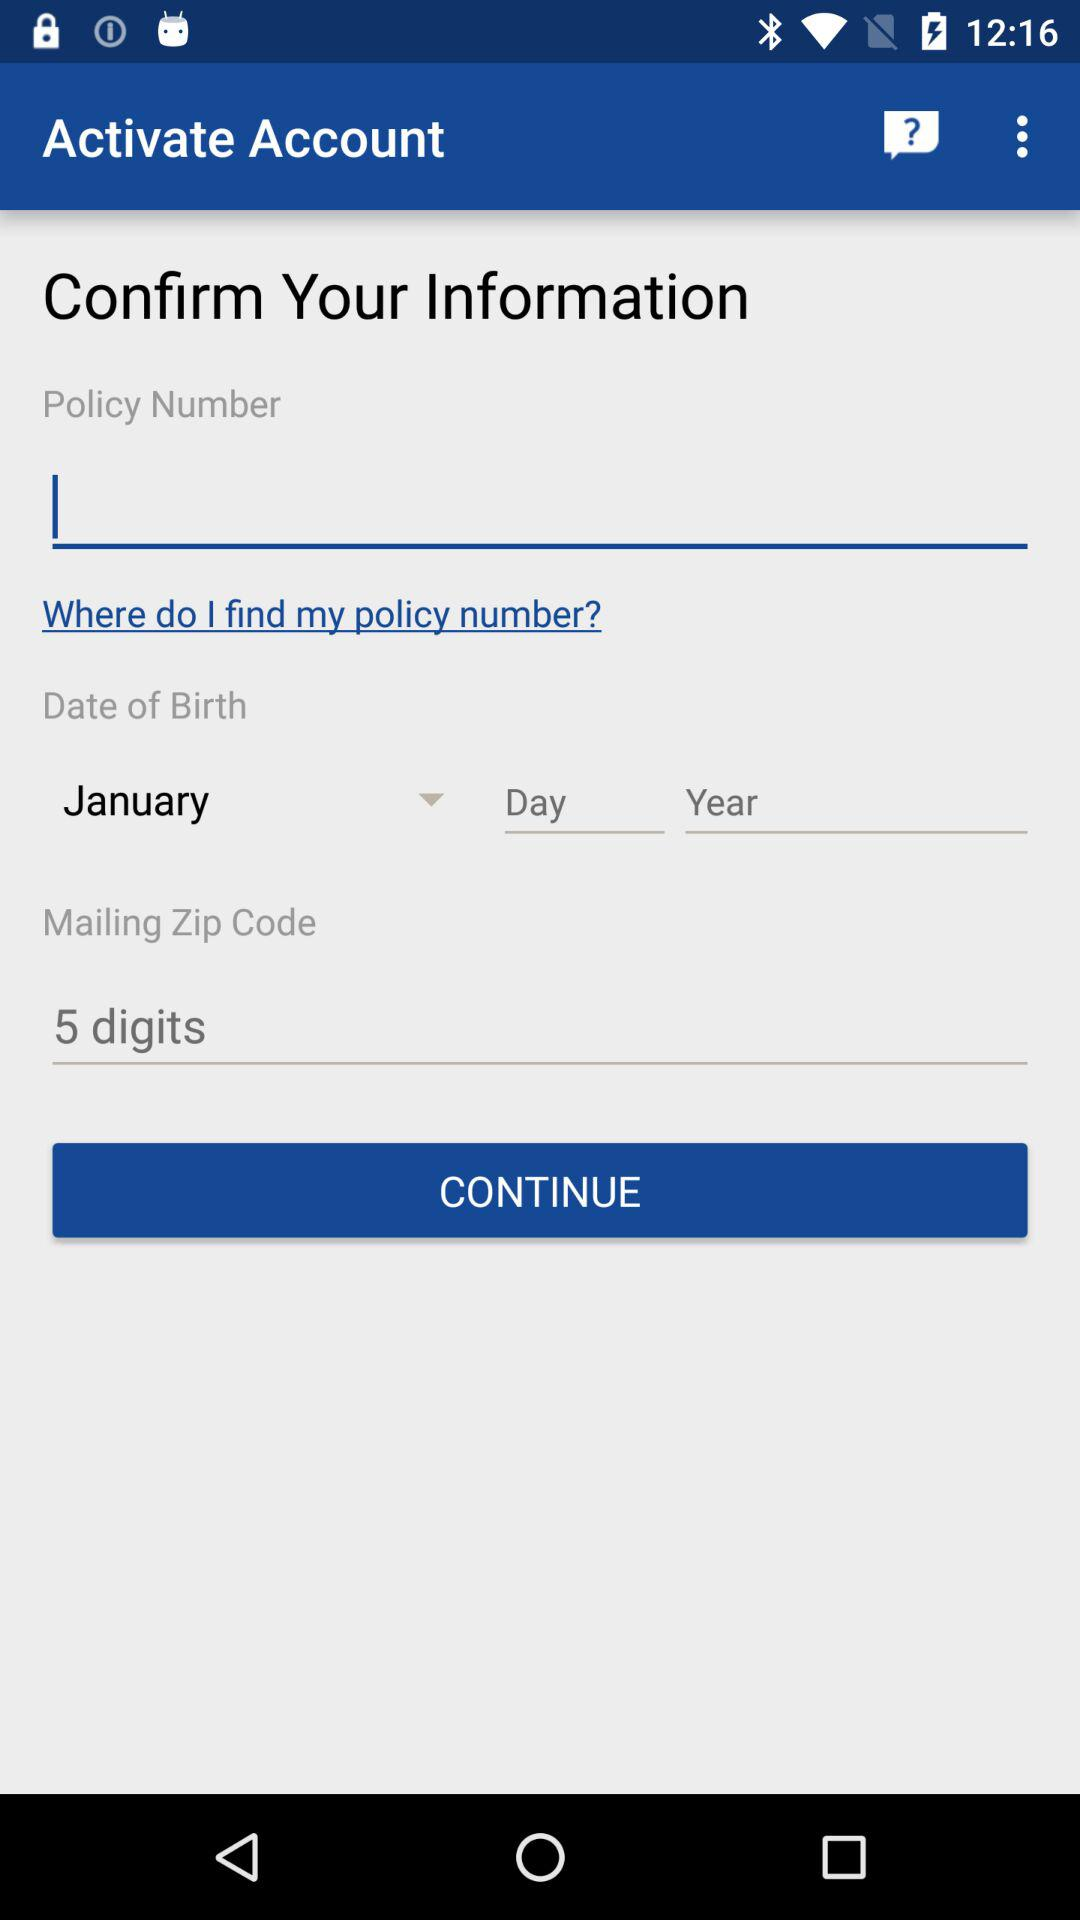How many digits are in the zip code field?
Answer the question using a single word or phrase. 5 